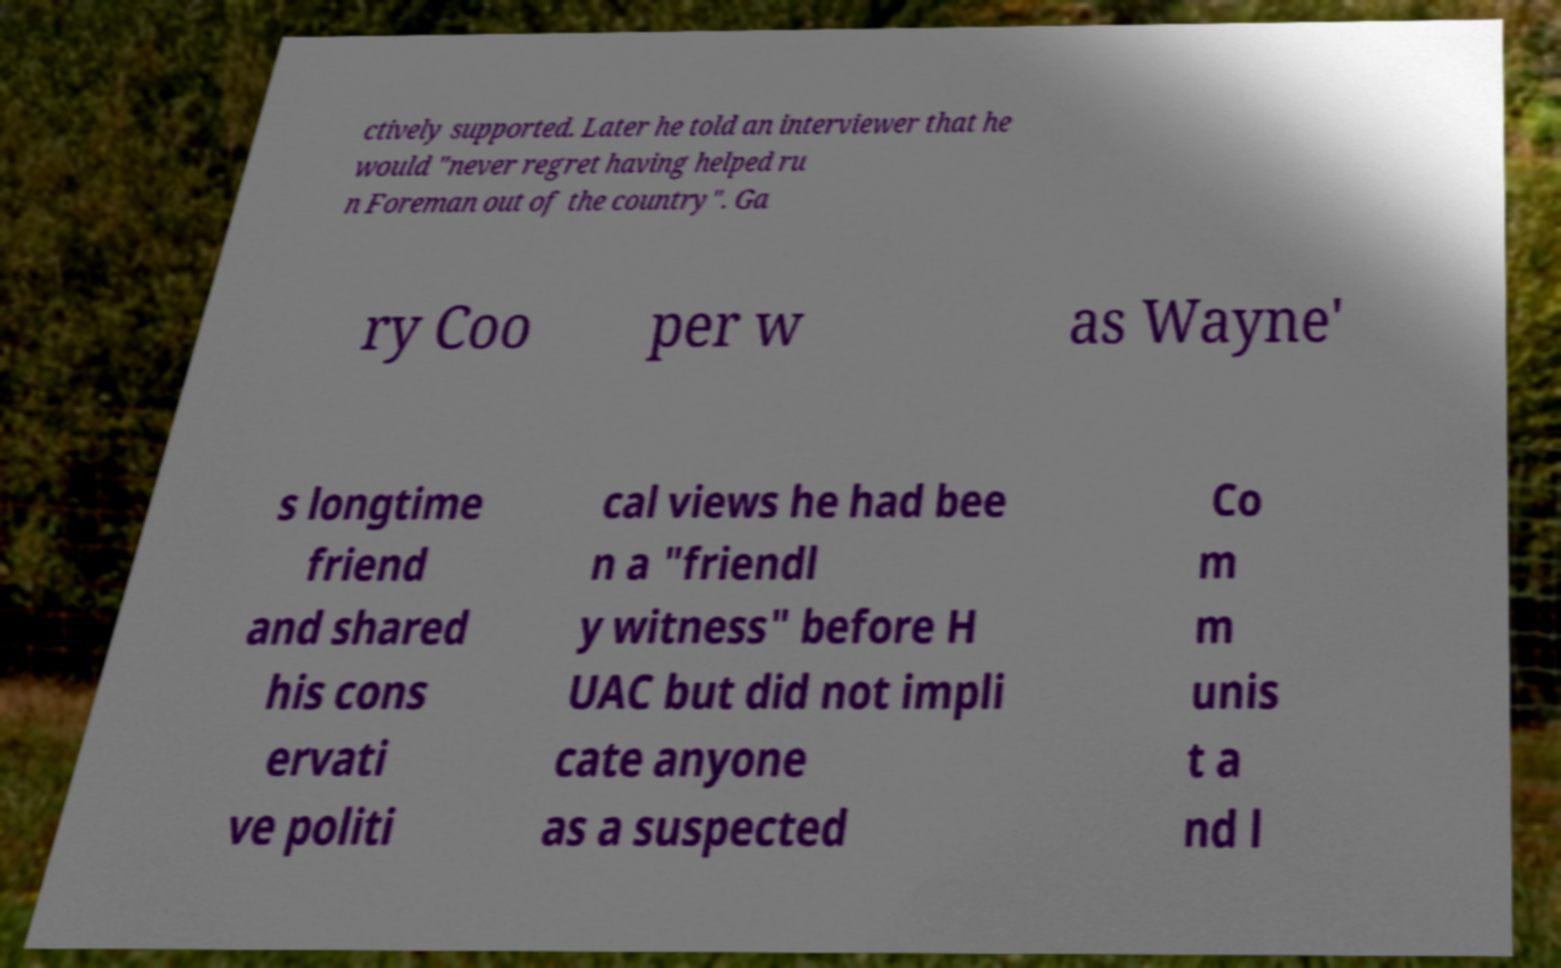Please identify and transcribe the text found in this image. ctively supported. Later he told an interviewer that he would "never regret having helped ru n Foreman out of the country". Ga ry Coo per w as Wayne' s longtime friend and shared his cons ervati ve politi cal views he had bee n a "friendl y witness" before H UAC but did not impli cate anyone as a suspected Co m m unis t a nd l 